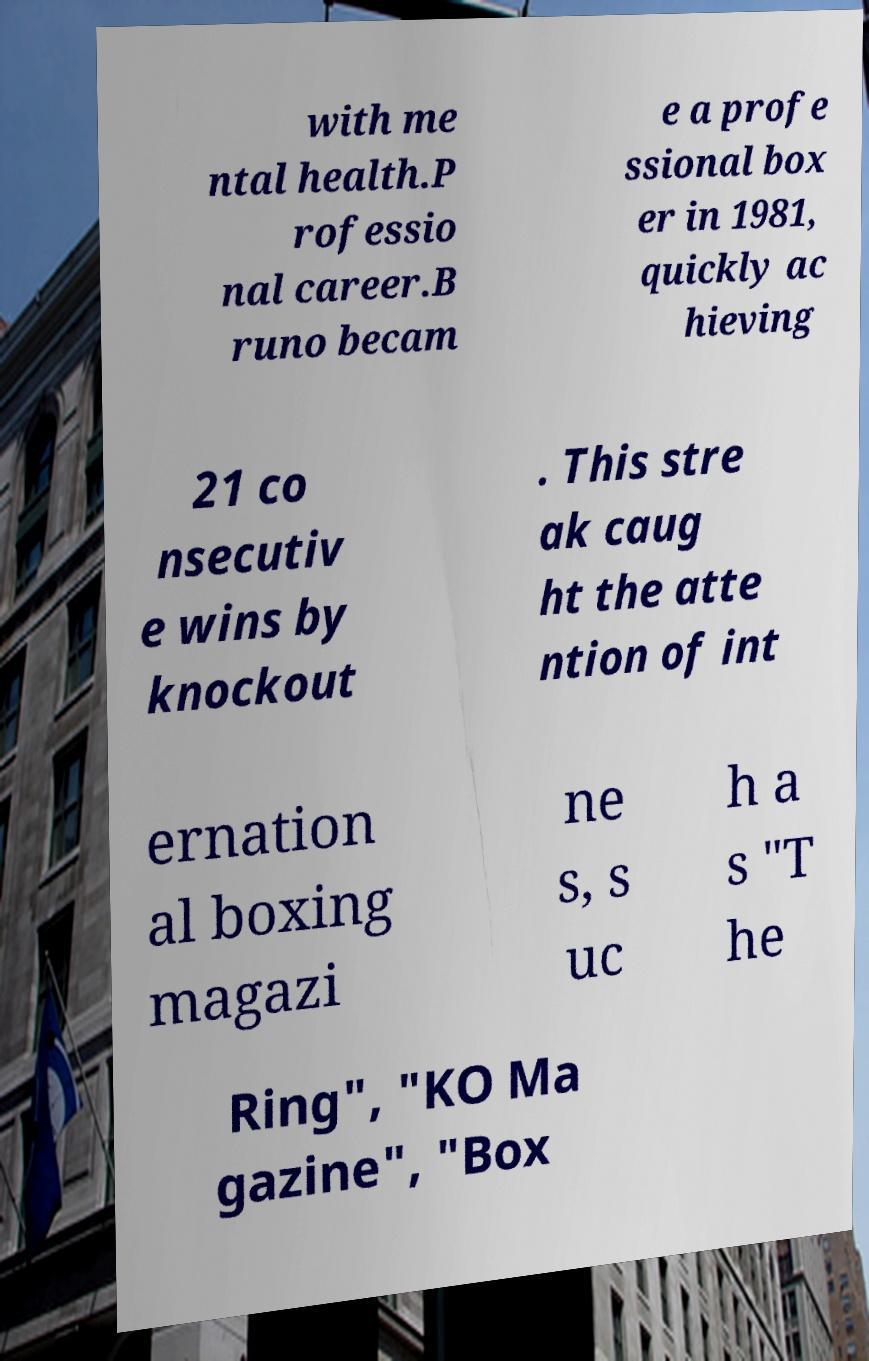There's text embedded in this image that I need extracted. Can you transcribe it verbatim? with me ntal health.P rofessio nal career.B runo becam e a profe ssional box er in 1981, quickly ac hieving 21 co nsecutiv e wins by knockout . This stre ak caug ht the atte ntion of int ernation al boxing magazi ne s, s uc h a s "T he Ring", "KO Ma gazine", "Box 